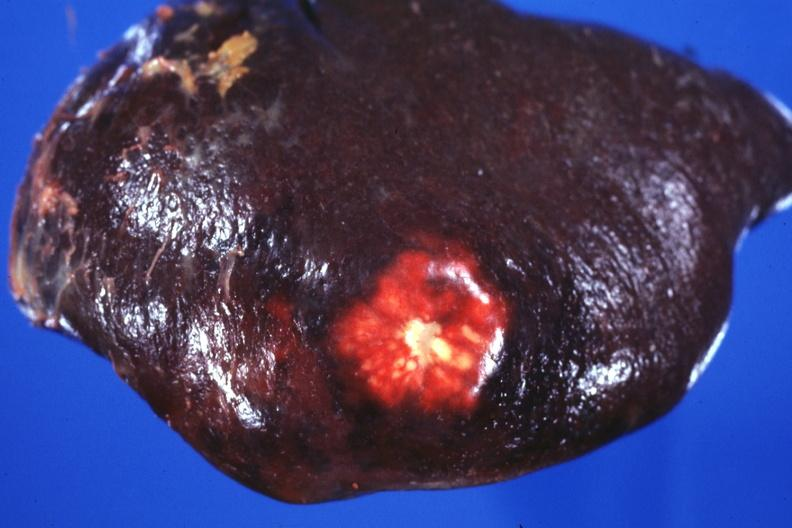s metastatic colon carcinoma present?
Answer the question using a single word or phrase. Yes 